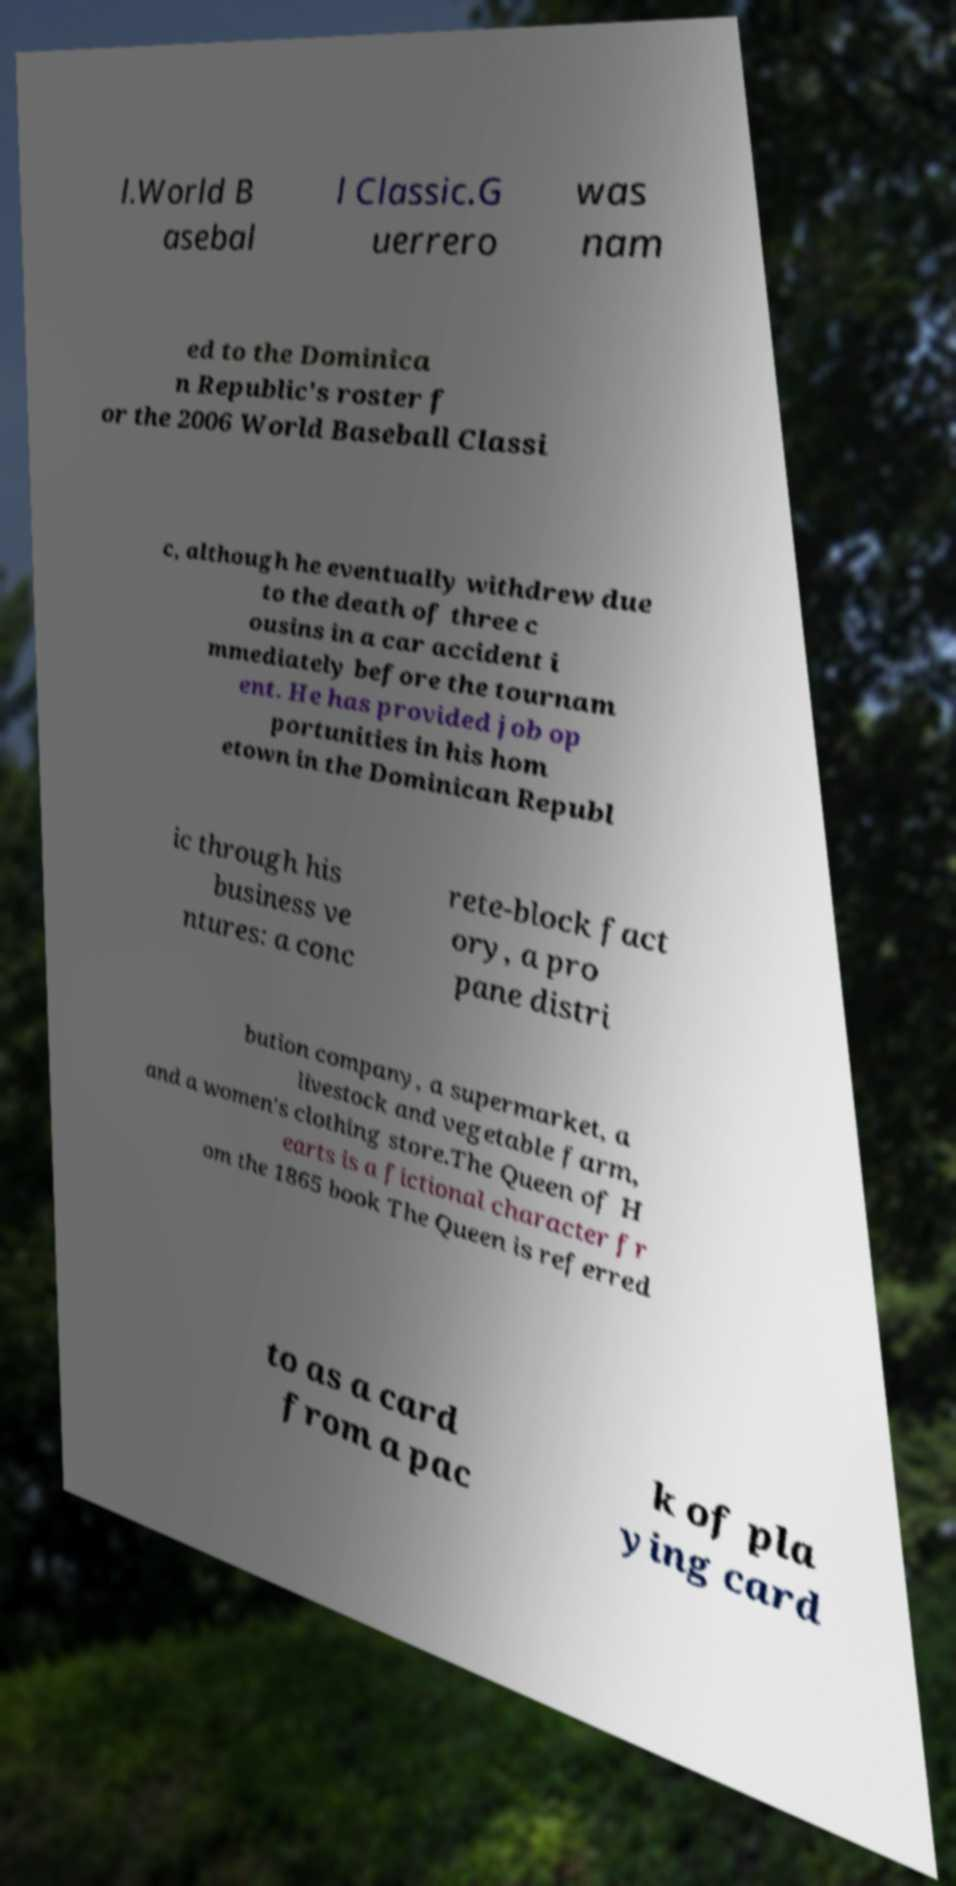Could you extract and type out the text from this image? l.World B asebal l Classic.G uerrero was nam ed to the Dominica n Republic's roster f or the 2006 World Baseball Classi c, although he eventually withdrew due to the death of three c ousins in a car accident i mmediately before the tournam ent. He has provided job op portunities in his hom etown in the Dominican Republ ic through his business ve ntures: a conc rete-block fact ory, a pro pane distri bution company, a supermarket, a livestock and vegetable farm, and a women's clothing store.The Queen of H earts is a fictional character fr om the 1865 book The Queen is referred to as a card from a pac k of pla ying card 